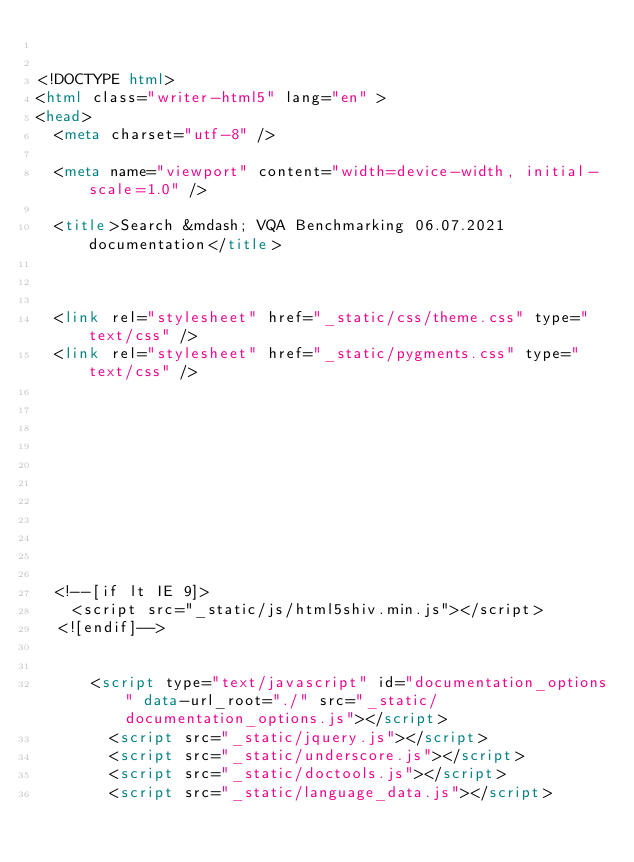Convert code to text. <code><loc_0><loc_0><loc_500><loc_500><_HTML_>

<!DOCTYPE html>
<html class="writer-html5" lang="en" >
<head>
  <meta charset="utf-8" />
  
  <meta name="viewport" content="width=device-width, initial-scale=1.0" />
  
  <title>Search &mdash; VQA Benchmarking 06.07.2021 documentation</title>
  

  
  <link rel="stylesheet" href="_static/css/theme.css" type="text/css" />
  <link rel="stylesheet" href="_static/pygments.css" type="text/css" />

  
  

  
  

  

  
    
  <!--[if lt IE 9]>
    <script src="_static/js/html5shiv.min.js"></script>
  <![endif]-->
  
    
      <script type="text/javascript" id="documentation_options" data-url_root="./" src="_static/documentation_options.js"></script>
        <script src="_static/jquery.js"></script>
        <script src="_static/underscore.js"></script>
        <script src="_static/doctools.js"></script>
        <script src="_static/language_data.js"></script>
    </code> 